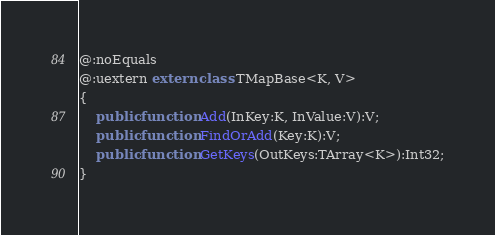<code> <loc_0><loc_0><loc_500><loc_500><_Haxe_>@:noEquals
@:uextern extern class TMapBase<K, V>
{
    public function Add(InKey:K, InValue:V):V;
    public function FindOrAdd(Key:K):V;
    public function GetKeys(OutKeys:TArray<K>):Int32;
}
</code> 